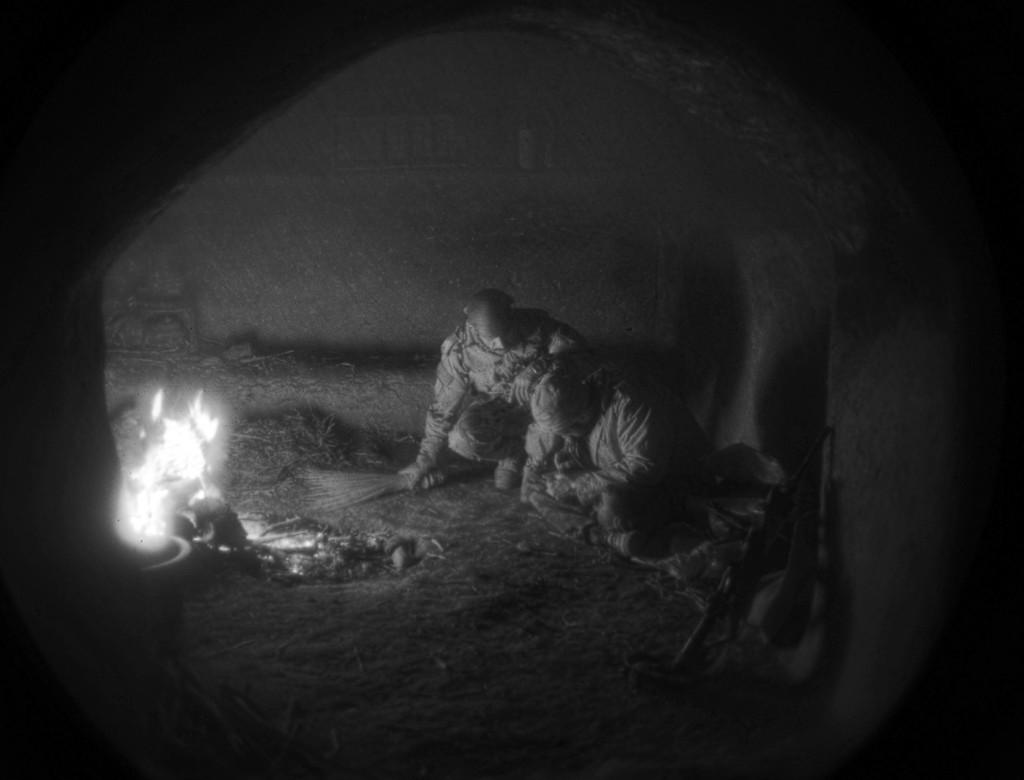What is the primary element in the image? There is fire in the image. What object can be seen near the fire? A broomstick is present in the image. What position are the two persons in the image? They are in a crouch or kneel position. What type of structure is visible in the image? There is a wall visible in the image. How many mice can be seen sneezing near the fire in the image? There are no mice present in the image, and therefore no sneezing can be observed. 